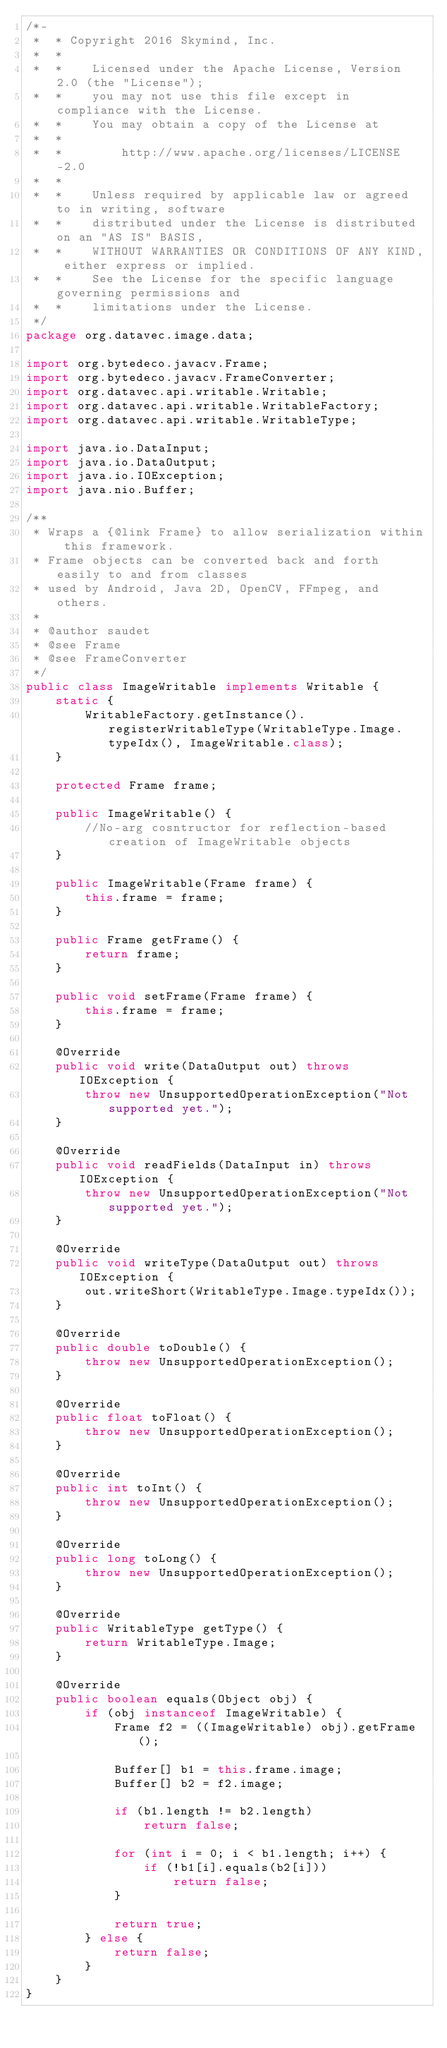Convert code to text. <code><loc_0><loc_0><loc_500><loc_500><_Java_>/*-
 *  * Copyright 2016 Skymind, Inc.
 *  *
 *  *    Licensed under the Apache License, Version 2.0 (the "License");
 *  *    you may not use this file except in compliance with the License.
 *  *    You may obtain a copy of the License at
 *  *
 *  *        http://www.apache.org/licenses/LICENSE-2.0
 *  *
 *  *    Unless required by applicable law or agreed to in writing, software
 *  *    distributed under the License is distributed on an "AS IS" BASIS,
 *  *    WITHOUT WARRANTIES OR CONDITIONS OF ANY KIND, either express or implied.
 *  *    See the License for the specific language governing permissions and
 *  *    limitations under the License.
 */
package org.datavec.image.data;

import org.bytedeco.javacv.Frame;
import org.bytedeco.javacv.FrameConverter;
import org.datavec.api.writable.Writable;
import org.datavec.api.writable.WritableFactory;
import org.datavec.api.writable.WritableType;

import java.io.DataInput;
import java.io.DataOutput;
import java.io.IOException;
import java.nio.Buffer;

/**
 * Wraps a {@link Frame} to allow serialization within this framework.
 * Frame objects can be converted back and forth easily to and from classes
 * used by Android, Java 2D, OpenCV, FFmpeg, and others.
 *
 * @author saudet
 * @see Frame
 * @see FrameConverter
 */
public class ImageWritable implements Writable {
    static {
        WritableFactory.getInstance().registerWritableType(WritableType.Image.typeIdx(), ImageWritable.class);
    }

    protected Frame frame;

    public ImageWritable() {
        //No-arg cosntructor for reflection-based creation of ImageWritable objects
    }

    public ImageWritable(Frame frame) {
        this.frame = frame;
    }

    public Frame getFrame() {
        return frame;
    }

    public void setFrame(Frame frame) {
        this.frame = frame;
    }

    @Override
    public void write(DataOutput out) throws IOException {
        throw new UnsupportedOperationException("Not supported yet.");
    }

    @Override
    public void readFields(DataInput in) throws IOException {
        throw new UnsupportedOperationException("Not supported yet.");
    }

    @Override
    public void writeType(DataOutput out) throws IOException {
        out.writeShort(WritableType.Image.typeIdx());
    }

    @Override
    public double toDouble() {
        throw new UnsupportedOperationException();
    }

    @Override
    public float toFloat() {
        throw new UnsupportedOperationException();
    }

    @Override
    public int toInt() {
        throw new UnsupportedOperationException();
    }

    @Override
    public long toLong() {
        throw new UnsupportedOperationException();
    }

    @Override
    public WritableType getType() {
        return WritableType.Image;
    }

    @Override
    public boolean equals(Object obj) {
        if (obj instanceof ImageWritable) {
            Frame f2 = ((ImageWritable) obj).getFrame();

            Buffer[] b1 = this.frame.image;
            Buffer[] b2 = f2.image;

            if (b1.length != b2.length)
                return false;

            for (int i = 0; i < b1.length; i++) {
                if (!b1[i].equals(b2[i]))
                    return false;
            }

            return true;
        } else {
            return false;
        }
    }
}
</code> 